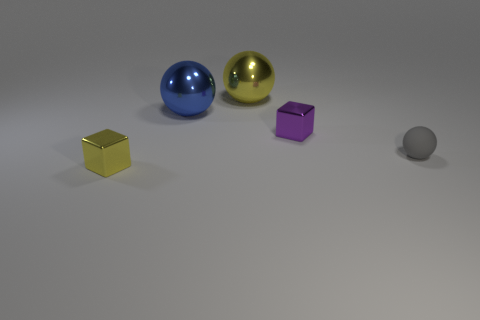Is there another gray matte object of the same size as the gray thing?
Ensure brevity in your answer.  No. There is a small shiny thing behind the yellow metallic thing in front of the gray ball; are there any yellow metal spheres right of it?
Provide a short and direct response. No. Is the color of the matte object the same as the metallic block that is in front of the tiny ball?
Offer a terse response. No. What material is the big thing left of the yellow metal object that is behind the small metallic block behind the tiny yellow shiny object made of?
Provide a short and direct response. Metal. There is a yellow object behind the blue metal sphere; what shape is it?
Ensure brevity in your answer.  Sphere. What is the size of the other cube that is made of the same material as the yellow cube?
Your answer should be compact. Small. What number of small red rubber things have the same shape as the tiny gray matte thing?
Provide a succinct answer. 0. Does the small metal block that is on the left side of the small purple metal object have the same color as the rubber ball?
Ensure brevity in your answer.  No. What number of small purple cubes are in front of the small metallic block that is to the right of the tiny cube left of the purple block?
Your response must be concise. 0. How many balls are both to the right of the big blue object and behind the small purple shiny thing?
Ensure brevity in your answer.  1. 